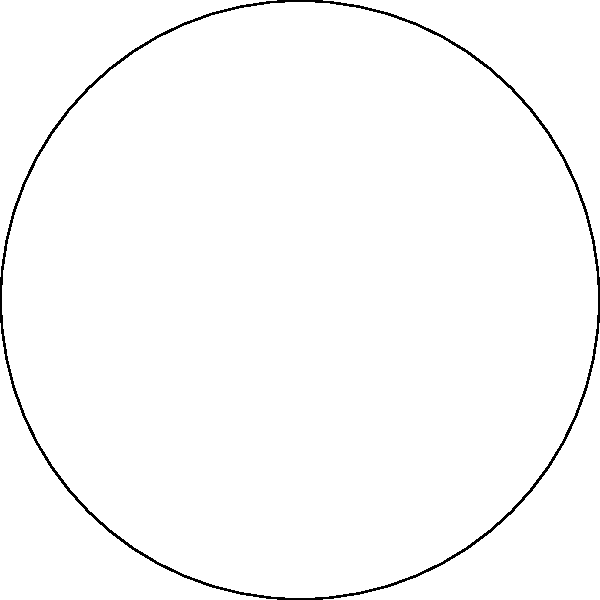A physical therapist has designed a new rotational exercise for spinal cord injury rehabilitation. The exercise diagram shows four numbered directions (1, 2, 3, 4) in which the patient should move their upper body. What is the order of the rotational symmetry group for this exercise diagram? To determine the order of the rotational symmetry group for this exercise diagram, we need to follow these steps:

1. Identify the rotations that bring the diagram back to its original orientation:
   - 0° (identity rotation)
   - 90° clockwise
   - 180° (half turn)
   - 270° clockwise (or 90° counterclockwise)

2. Count the number of these rotations:
   There are 4 rotations that preserve the diagram's appearance.

3. Understand that these rotations form a cyclic group $C_4$:
   - The group operation is composition of rotations.
   - The identity element is the 0° rotation.
   - Each rotation has an inverse (e.g., 90° clockwise and 270° clockwise are inverses).
   - The group is closed under composition.

4. Recall that the order of a group is the number of elements in the group.

Therefore, the order of the rotational symmetry group for this exercise diagram is 4.
Answer: 4 